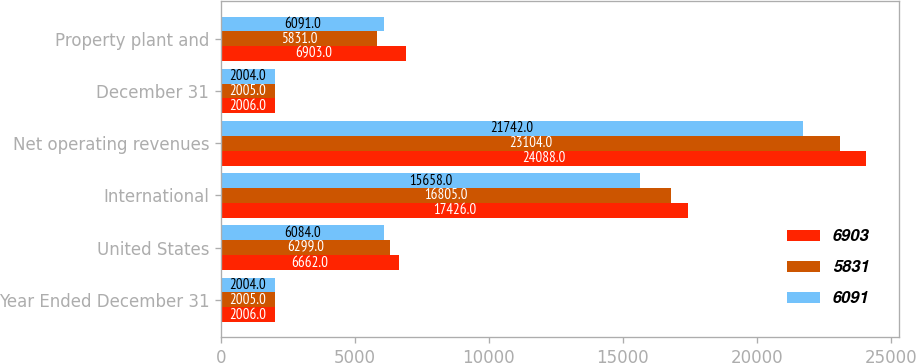Convert chart. <chart><loc_0><loc_0><loc_500><loc_500><stacked_bar_chart><ecel><fcel>Year Ended December 31<fcel>United States<fcel>International<fcel>Net operating revenues<fcel>December 31<fcel>Property plant and<nl><fcel>6903<fcel>2006<fcel>6662<fcel>17426<fcel>24088<fcel>2006<fcel>6903<nl><fcel>5831<fcel>2005<fcel>6299<fcel>16805<fcel>23104<fcel>2005<fcel>5831<nl><fcel>6091<fcel>2004<fcel>6084<fcel>15658<fcel>21742<fcel>2004<fcel>6091<nl></chart> 